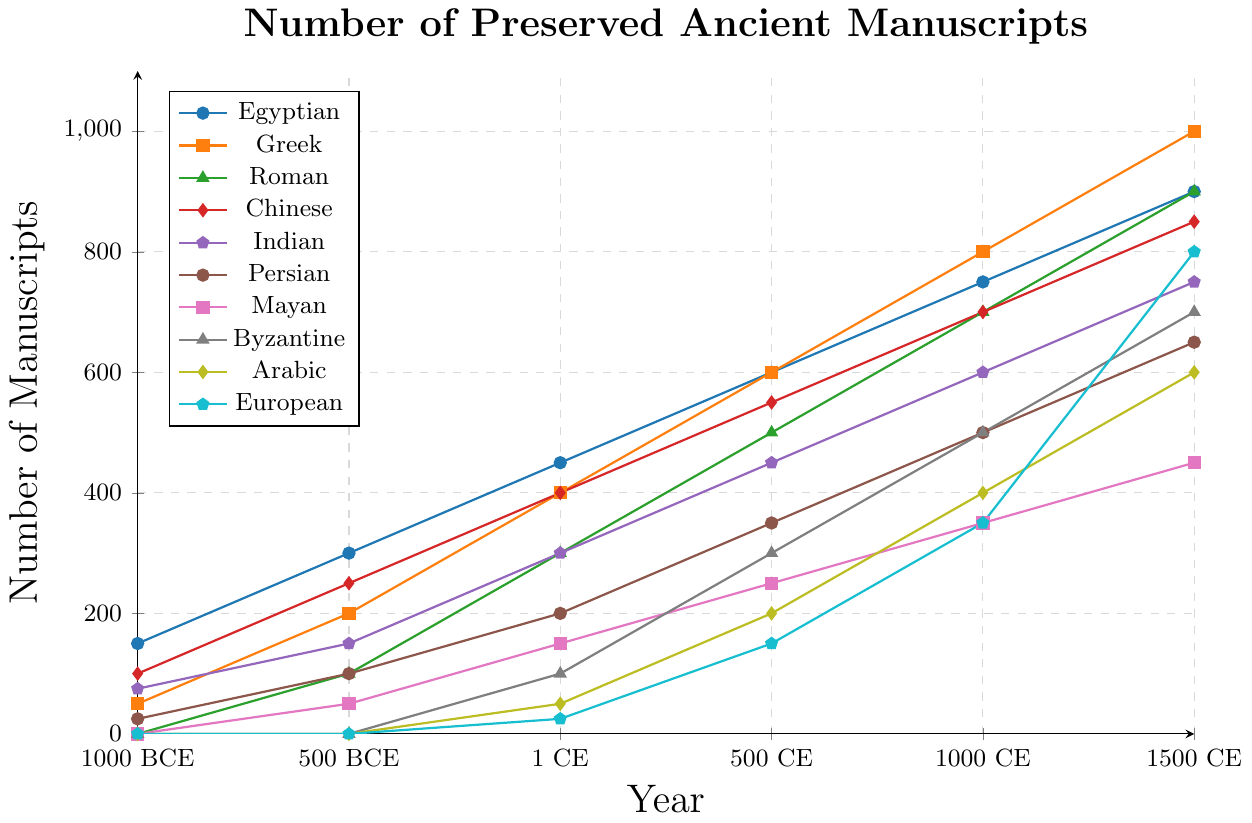What's the total number of preserved manuscripts for Egyptian civilization by 1500 CE? To find the total number of preserved manuscripts for the Egyptian civilization by 1500 CE, sum all the values listed for the Egyptian civilization: 150 + 300 + 450 + 600 + 750 + 900 = 3150
Answer: 3150 Which civilization has the highest number of preserved manuscripts by 1 CE? Compare the numbers of preserved manuscripts for each civilization by 1 CE: Egyptian (450), Greek (400), Roman (300), Chinese (400), Indian (300), Persian (200), Mayan (150), Byzantine (100), Arabic (50), European (25). The Egyptian civilization has the highest number.
Answer: Egyptian Between 1 CE and 500 CE, which civilization shows the greatest increase in the number of manuscripts? Calculate the difference in the number of manuscripts between 1 CE and 500 CE for each civilization. The increases are: Egyptian (600-450 = 150), Greek (600-400 = 200), Roman (500-300 = 200), Chinese (550-400 = 150), Indian (450-300 = 150), Persian (350-200 = 150), Mayan (250-150 = 100), Byzantine (300-100 = 200), Arabic (200-50 = 150), European (150-25 = 125). Byzantine, Greek, and Roman each show the greatest increase of 200 manuscripts.
Answer: Byzantine, Greek, Roman Which civilization first reached 500 manuscripts? Check when each civilization first reached 500 manuscripts. Egyptian reached 500 by 500 CE, Greek by 1 CE, Roman by 500 CE, Chinese by 500 CE, Indian by 500 CE, Persian never reached 500 by 500 CE, Mayan never reached 500 by 500 CE, Byzantine never reached 500 by 500 CE, Arabic never reached 500 by 500 CE, European never reached 500 by 500 CE. Greek reached it first by 1 CE.
Answer: Greek At which year did the Byzantine civilization first show preserved manuscripts? Look at the plotted values for Byzantine. The first nonzero value is at 1 CE, when there are 100 manuscripts.
Answer: 1 CE Compare the growth of preserved manuscripts between Egyptian and Greek civilizations from 1000 BCE to 1500 CE. Calculate the increase in manuscripts for each civilization from 1000 BCE to 1500 CE. Egyptian: 900 - 150 = 750, Greek: 1000 - 50 = 950. The Greek civilization shows greater growth.
Answer: Greek What is the average number of manuscripts for the Indian civilization across all historical periods? Sum all the values for the Indian civilization and divide by the number of periods (6): (75 + 150 + 300 + 450 + 600 + 750)/6 = 2325/6 = 387.5.
Answer: 387.5 How many civilizations had 0 manuscripts in 1000 BCE? Identify the civilizations with 0 manuscripts in 1000 BCE: Roman, Mayan, Byzantine, Arabic, European. There are 5 civilizations.
Answer: 5 Which civilization exhibits the fastest growth in the number of manuscripts from 1000 CE to 1500 CE? Calculate the growth for each civilization from 1000 CE to 1500 CE and compare. Egyptian: 900 - 750 = 150, Greek: 1000 - 800 = 200, Roman: 900 - 700 = 200, Chinese: 850 - 700 = 150, Indian: 750 - 600 = 150, Persian: 650 - 500 = 150, Mayan: 450 - 350 = 100, Byzantine: 700 - 500 = 200, Arabic: 600 - 400 = 200, European: 800 - 350 = 450. European civilization exhibits the fastest growth.
Answer: European 